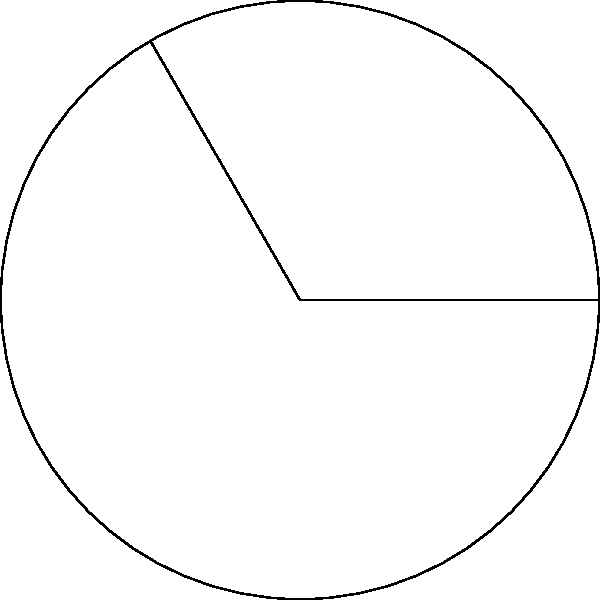In your latest album review, you've decided to use a circular sector to represent the balance between different musical elements. The circular sector has a central angle of 120° and a radius of 10 cm. Calculate the area of this sector, which will symbolize the portion of the album that achieves perfect harmony. Round your answer to two decimal places. To find the area of a circular sector, we'll follow these steps:

1) The formula for the area of a circular sector is:

   $$A = \frac{1}{2}r^2\theta$$

   Where $A$ is the area, $r$ is the radius, and $\theta$ is the central angle in radians.

2) We're given the angle in degrees (120°), so we need to convert it to radians:

   $$\theta = 120° \times \frac{\pi}{180°} = \frac{2\pi}{3} \approx 2.0944 \text{ radians}$$

3) Now we can substitute the values into our formula:

   $$A = \frac{1}{2} \times 10^2 \times \frac{2\pi}{3}$$

4) Simplify:

   $$A = \frac{100\pi}{3} \approx 104.72 \text{ cm}^2$$

5) Rounding to two decimal places:

   $$A \approx 104.72 \text{ cm}^2$$

This area represents the portion of the album that achieves perfect harmony in your review.
Answer: 104.72 cm² 